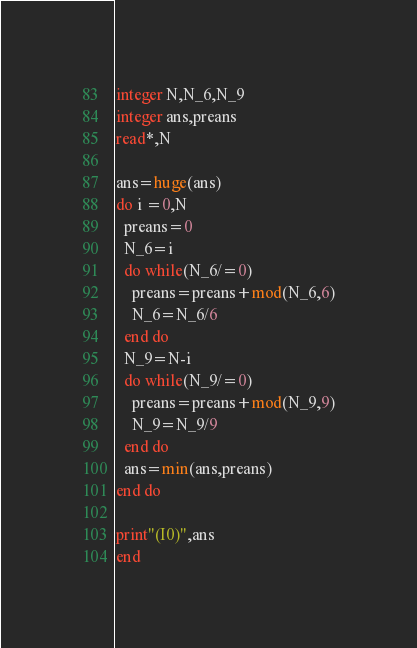<code> <loc_0><loc_0><loc_500><loc_500><_FORTRAN_>integer N,N_6,N_9
integer ans,preans
read*,N

ans=huge(ans)
do i =0,N
  preans=0
  N_6=i
  do while(N_6/=0)
    preans=preans+mod(N_6,6)
    N_6=N_6/6
  end do
  N_9=N-i
  do while(N_9/=0)
    preans=preans+mod(N_9,9)
    N_9=N_9/9
  end do
  ans=min(ans,preans)
end do

print"(I0)",ans
end</code> 